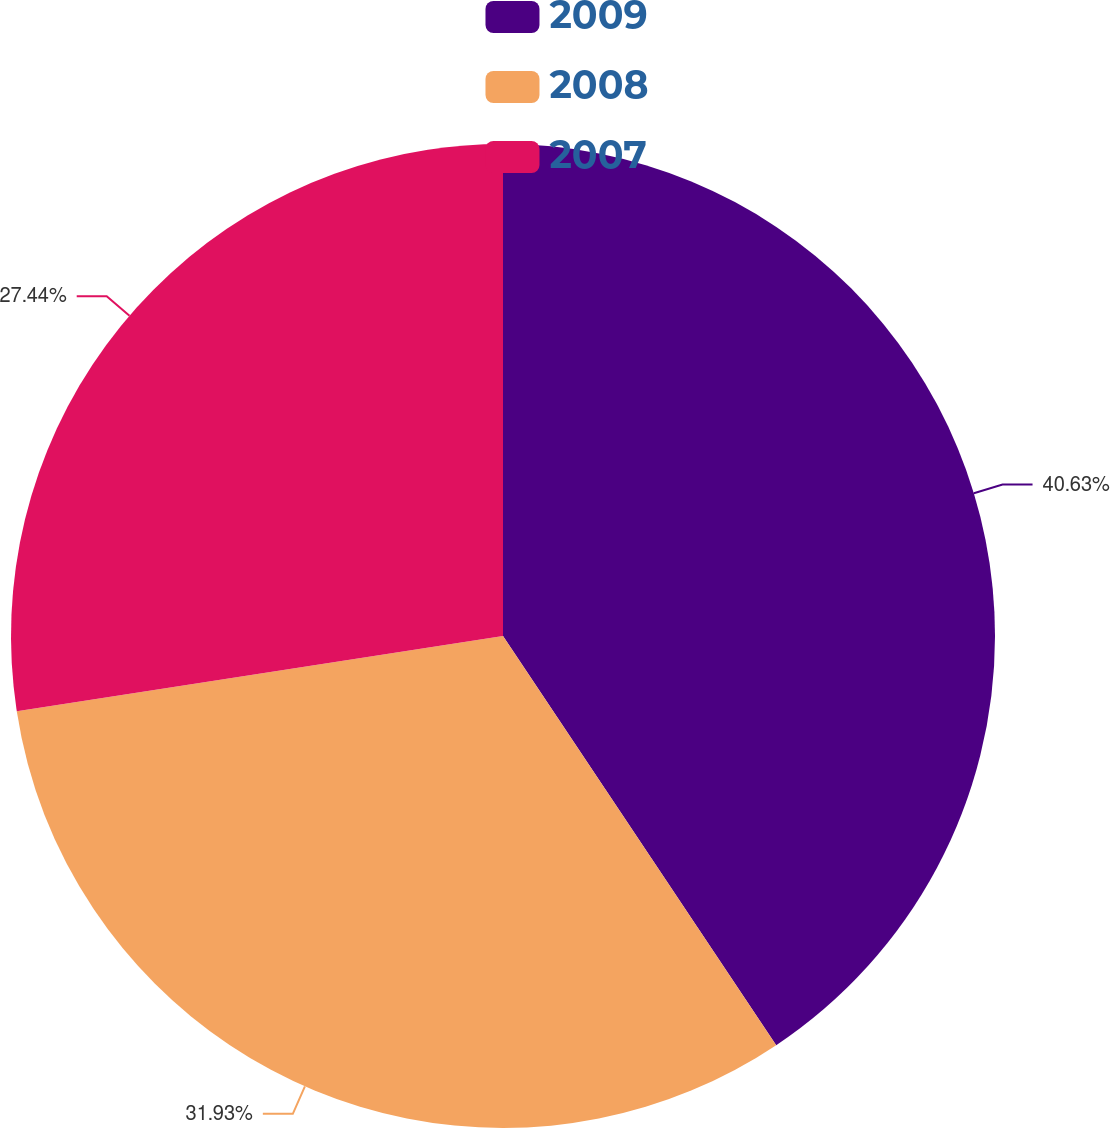Convert chart. <chart><loc_0><loc_0><loc_500><loc_500><pie_chart><fcel>2009<fcel>2008<fcel>2007<nl><fcel>40.63%<fcel>31.93%<fcel>27.44%<nl></chart> 